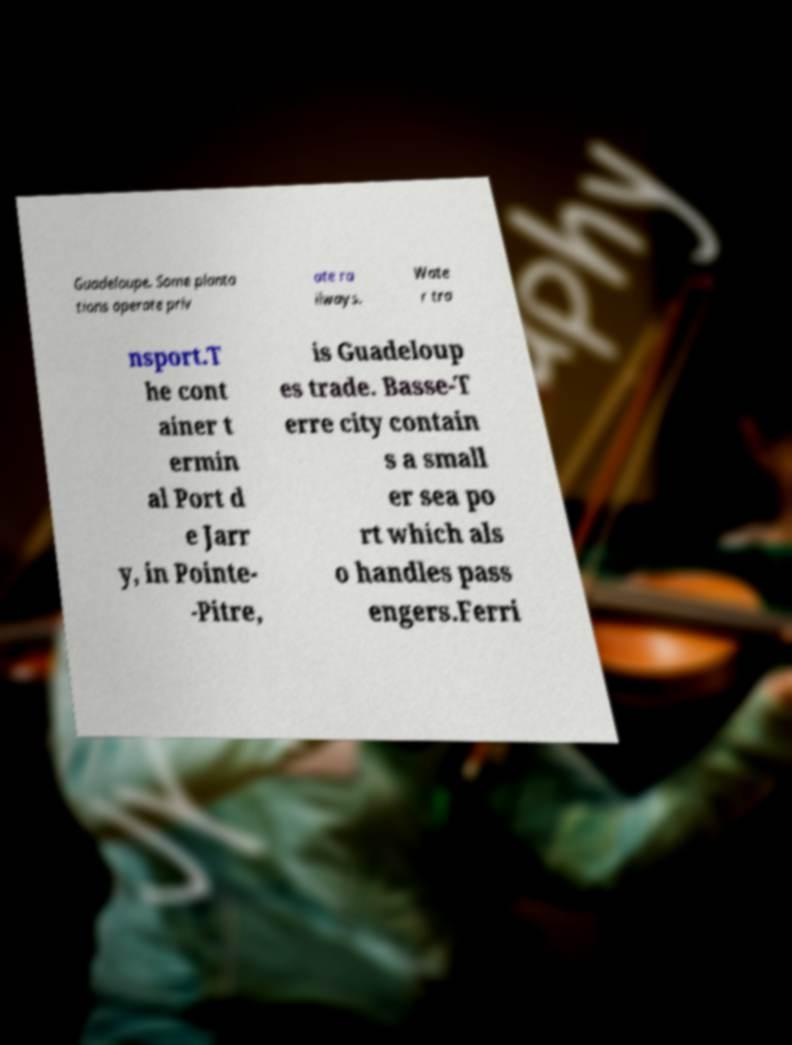Could you extract and type out the text from this image? Guadeloupe. Some planta tions operate priv ate ra ilways. Wate r tra nsport.T he cont ainer t ermin al Port d e Jarr y, in Pointe- -Pitre, is Guadeloup es trade. Basse-T erre city contain s a small er sea po rt which als o handles pass engers.Ferri 